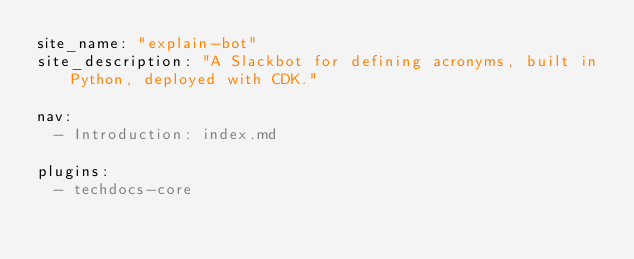Convert code to text. <code><loc_0><loc_0><loc_500><loc_500><_YAML_>site_name: "explain-bot"
site_description: "A Slackbot for defining acronyms, built in Python, deployed with CDK."

nav:
  - Introduction: index.md

plugins:
  - techdocs-core</code> 